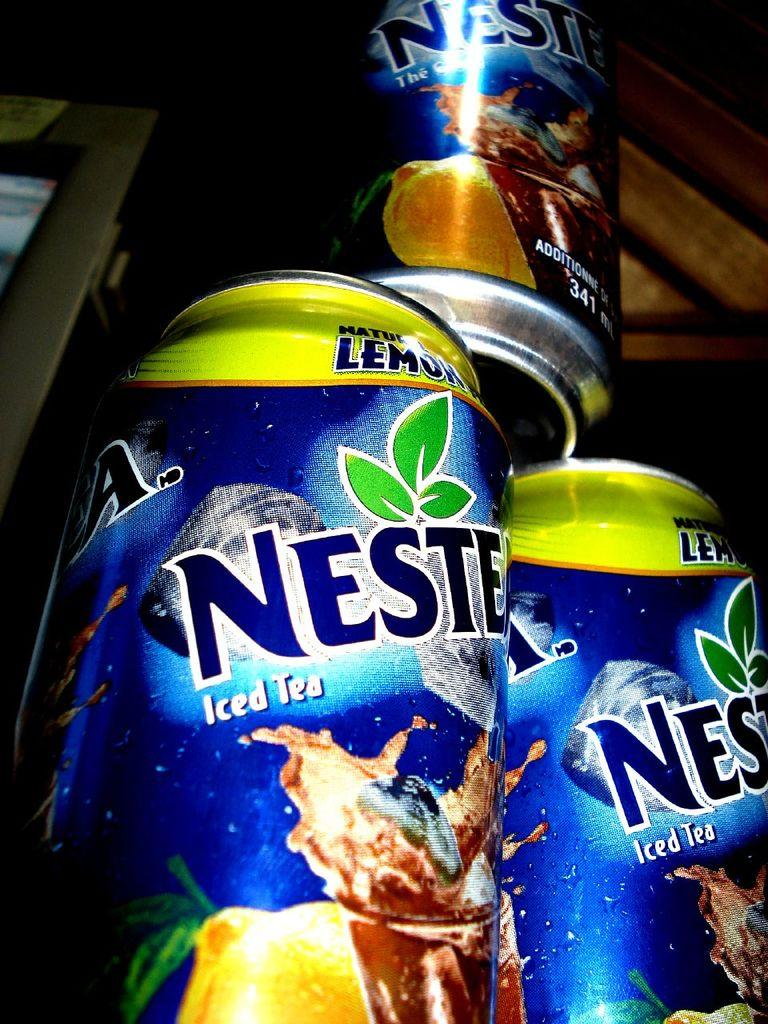What type of objects are in the image? There are tens in the image, along with other objects. Can you describe any specific features of these objects? Some of the objects have text and images on them. How does the bread twist in the image? There is no bread present in the image, so it cannot twist. What is the head doing in the image? There is no head present in the image, so it cannot be performing any action. 